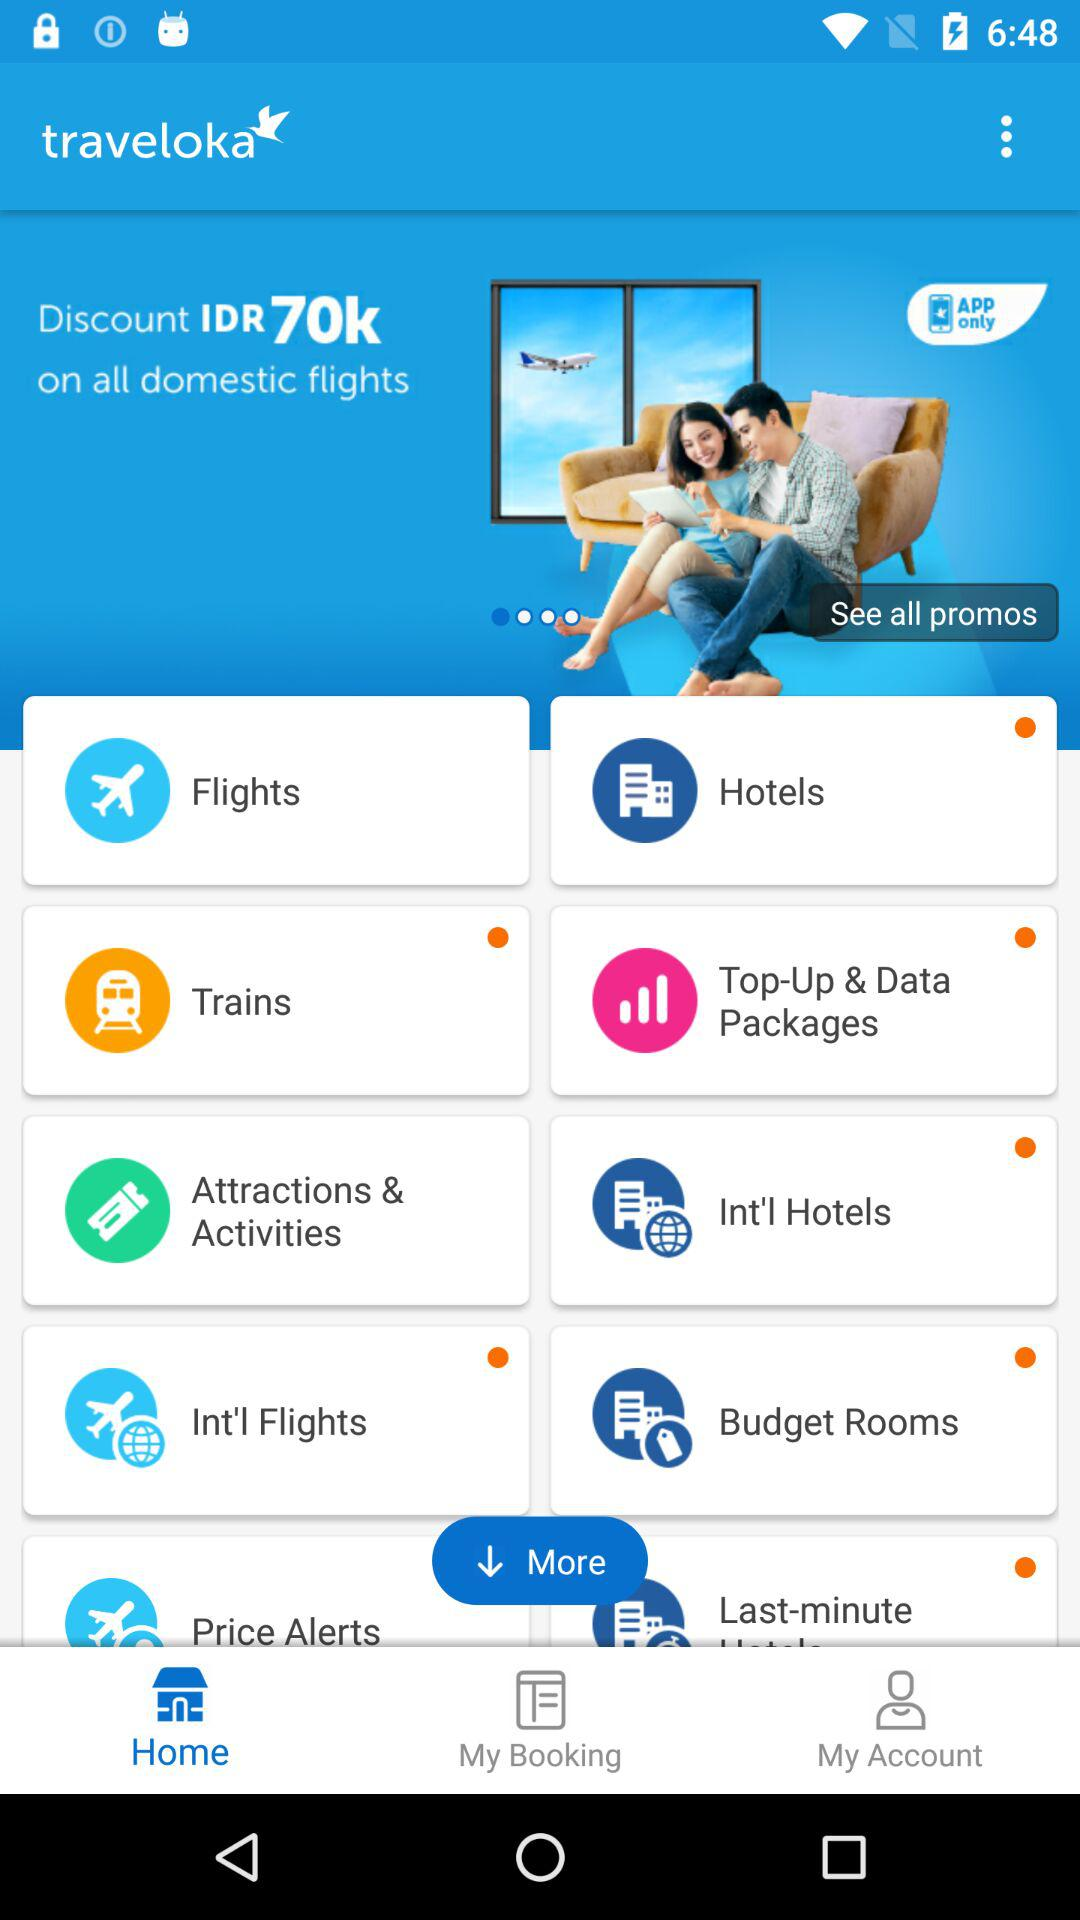What is the name of the application? The name of the application is "traveloka". 